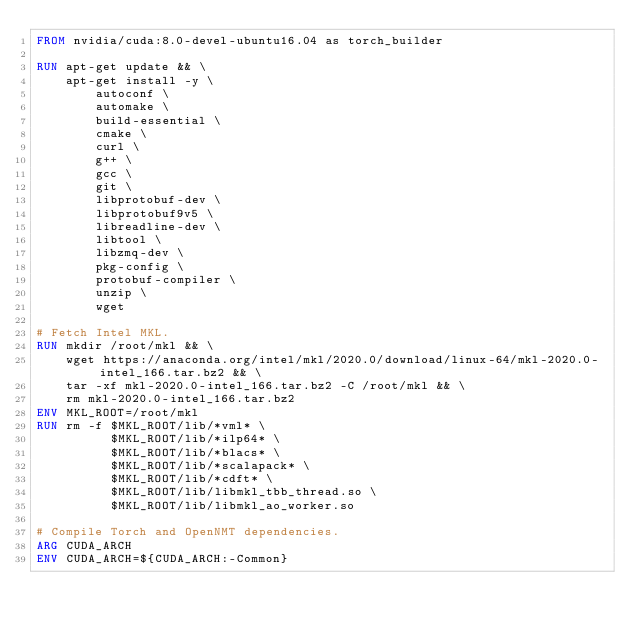<code> <loc_0><loc_0><loc_500><loc_500><_Dockerfile_>FROM nvidia/cuda:8.0-devel-ubuntu16.04 as torch_builder

RUN apt-get update && \
    apt-get install -y \
        autoconf \
        automake \
        build-essential \
        cmake \
        curl \
        g++ \
        gcc \
        git \
        libprotobuf-dev \
        libprotobuf9v5 \
        libreadline-dev \
        libtool \
        libzmq-dev \
        pkg-config \
        protobuf-compiler \
        unzip \
        wget

# Fetch Intel MKL.
RUN mkdir /root/mkl && \
    wget https://anaconda.org/intel/mkl/2020.0/download/linux-64/mkl-2020.0-intel_166.tar.bz2 && \
    tar -xf mkl-2020.0-intel_166.tar.bz2 -C /root/mkl && \
    rm mkl-2020.0-intel_166.tar.bz2
ENV MKL_ROOT=/root/mkl
RUN rm -f $MKL_ROOT/lib/*vml* \
          $MKL_ROOT/lib/*ilp64* \
          $MKL_ROOT/lib/*blacs* \
          $MKL_ROOT/lib/*scalapack* \
          $MKL_ROOT/lib/*cdft* \
          $MKL_ROOT/lib/libmkl_tbb_thread.so \
          $MKL_ROOT/lib/libmkl_ao_worker.so

# Compile Torch and OpenNMT dependencies.
ARG CUDA_ARCH
ENV CUDA_ARCH=${CUDA_ARCH:-Common}</code> 